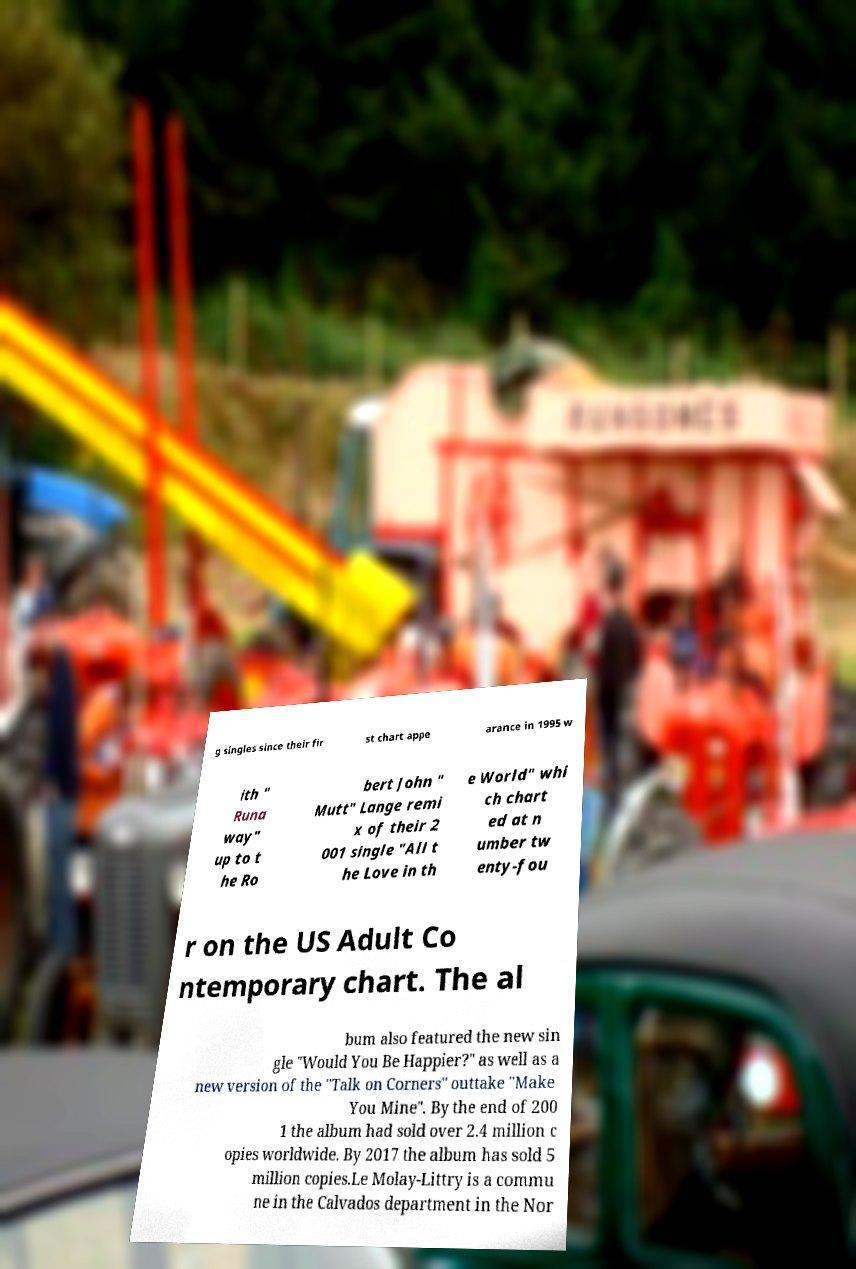Can you accurately transcribe the text from the provided image for me? g singles since their fir st chart appe arance in 1995 w ith " Runa way" up to t he Ro bert John " Mutt" Lange remi x of their 2 001 single "All t he Love in th e World" whi ch chart ed at n umber tw enty-fou r on the US Adult Co ntemporary chart. The al bum also featured the new sin gle "Would You Be Happier?" as well as a new version of the "Talk on Corners" outtake "Make You Mine". By the end of 200 1 the album had sold over 2.4 million c opies worldwide. By 2017 the album has sold 5 million copies.Le Molay-Littry is a commu ne in the Calvados department in the Nor 